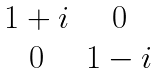Convert formula to latex. <formula><loc_0><loc_0><loc_500><loc_500>\begin{matrix} 1 + i & 0 \\ 0 & 1 - i \end{matrix}</formula> 